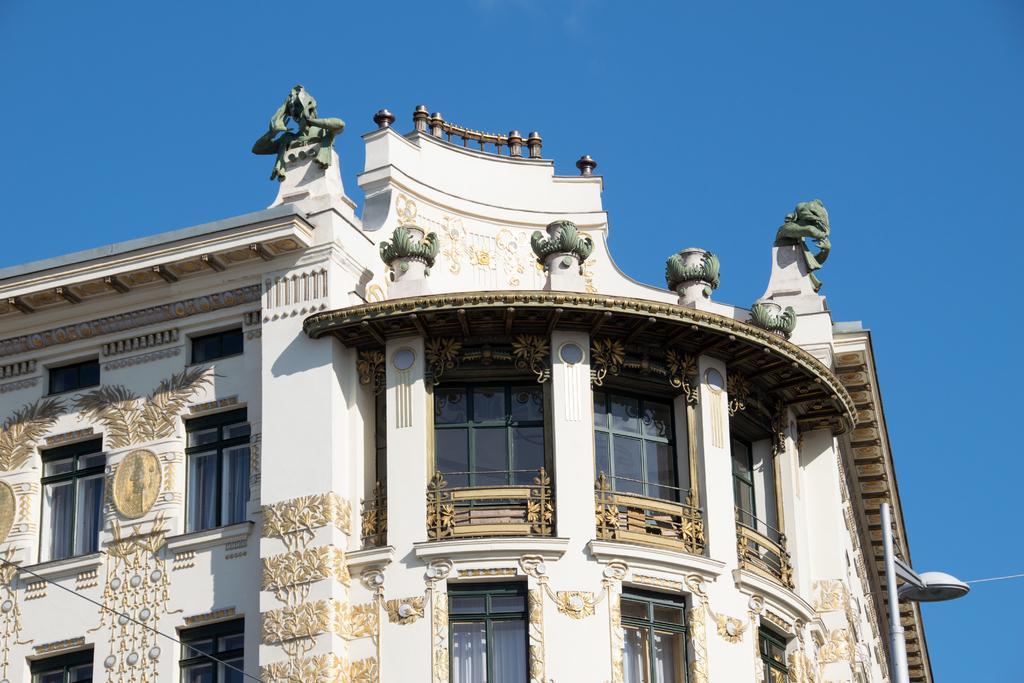In one or two sentences, can you explain what this image depicts? In the image there is a building with walls, glass windows, pillars, sculptures and also there is a roof. On the building walls there are designs. On the right side of the image there is a pole with lamp. And in the background there is a sky. 